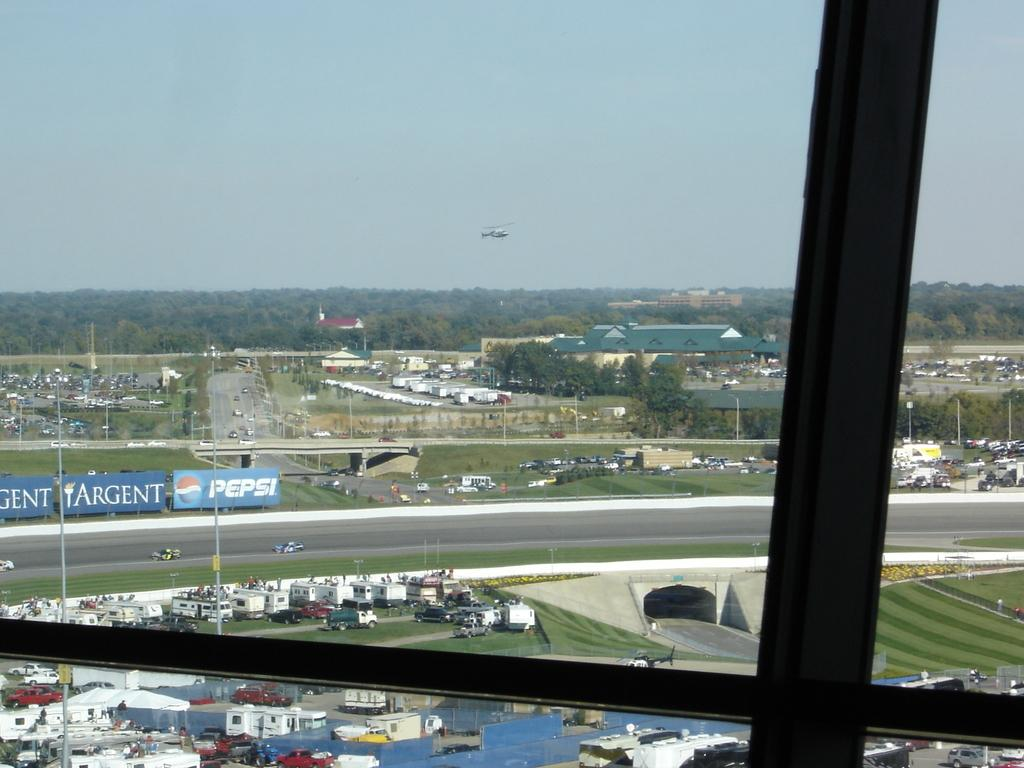<image>
Provide a brief description of the given image. A Pepsi banner is displayed across the road 